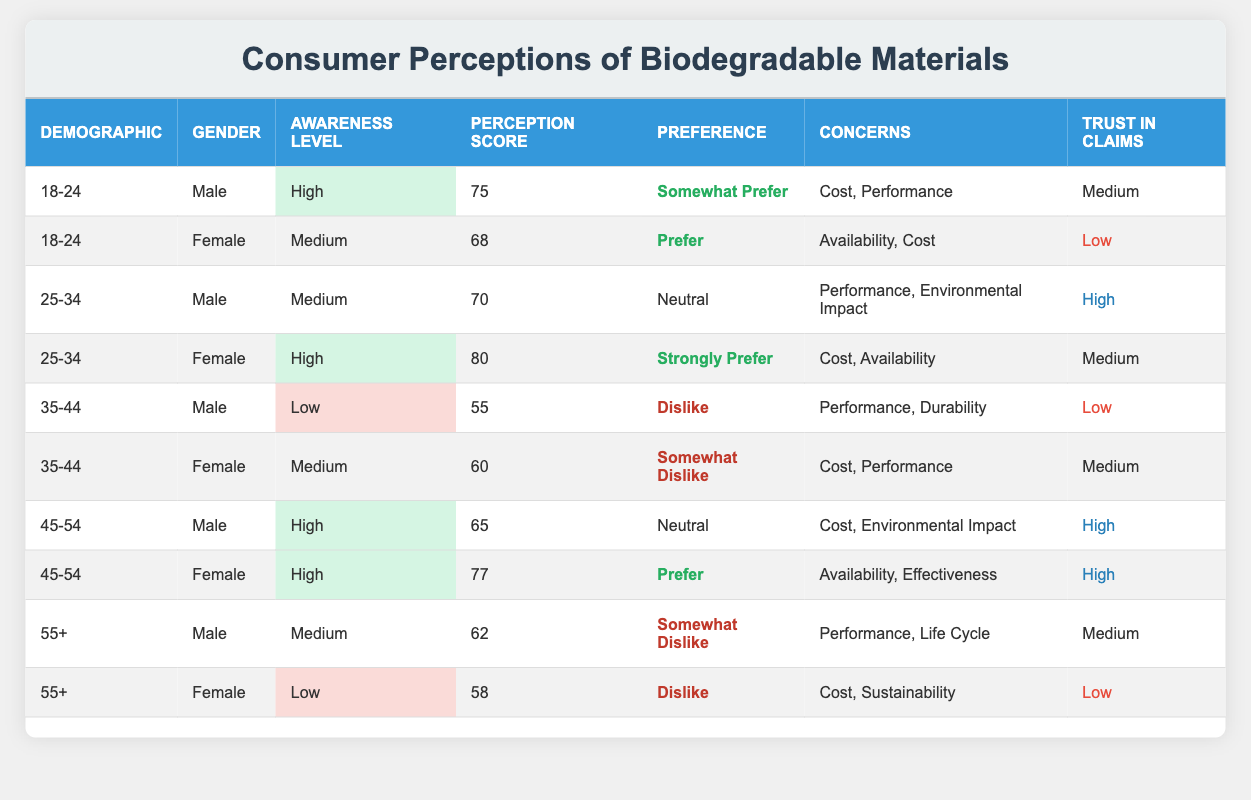What is the perception score of female consumers aged 25-34? Referring to the table, the perception score for the female demographic aged 25-34 is listed as 80.
Answer: 80 Which gender in the 35-44 age demographic has the lowest perception score? In the table, the male consumer aged 35-44 has a perception score of 55, while the female has a perception score of 60. Hence, the male has the lowest score.
Answer: Male What is the average perception score for consumers aged 45-54? The perception scores for the 45-54 age group are 65 (male) and 77 (female). The average is (65 + 77) / 2 = 71.
Answer: 71 Do any males aged 55 or older prefer biodegradable materials? The data shows that males in the 55+ demographic have "Somewhat Dislike" as their preference. Therefore, the answer is no.
Answer: No How many female consumers have a high awareness level? Upon examining the table, there are four females with high awareness: ages 25-34 (80 score), and 45-54 (77 score).
Answer: 2 What concerns are mentioned by male consumers aged 45-54? The table indicates that male consumers aged 45-54 are concerned about "Cost" and "Environmental Impact."
Answer: Cost, Environmental Impact Is there a demographic group where all members have a preference of "Somewhat Dislike" or "Dislike"? Looking through the table, the 35-44 male and 55+ female groups both express preferences of "Dislike" or "Somewhat Dislike." Thus, the answer is yes.
Answer: Yes Find the difference in perception scores between females aged 25-34 and 35-44. The table shows that females aged 25-34 have a score of 80, while those aged 35-44 have a score of 60. The difference is 80 - 60 = 20.
Answer: 20 Which demographic group has the highest trust in claims regarding biodegradable materials? The table shows that both the male and female consumers aged 25-34 and those aged 45-54 have high trust levels. However, among those, male consumers aged 25-34 specifically exhibit the highest trust level.
Answer: 25-34 Male What preference do most male consumers aged 35-44 show towards biodegradable materials? The male consumers aged 35-44 demonstrate a "Dislike" preference for biodegradable materials, which is noted in the table.
Answer: Dislike 